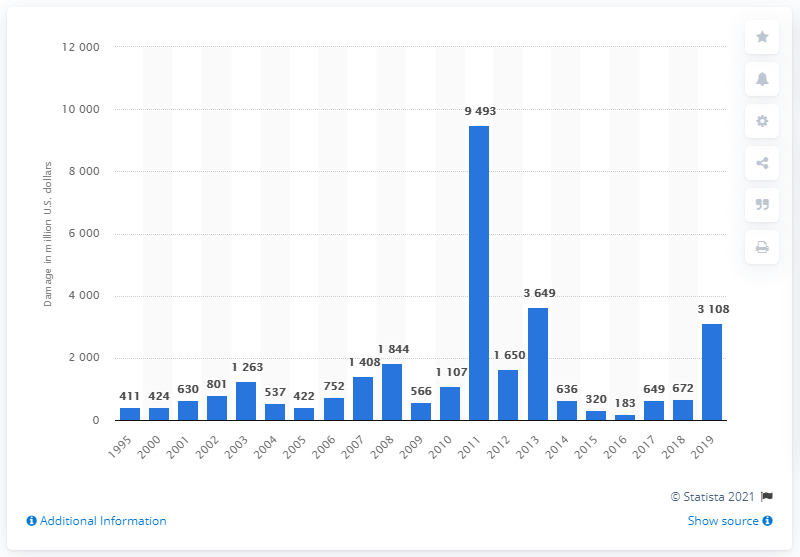Identify some key points in this picture. The total damage caused by tornadoes in 2019 was estimated to be approximately 3108. 